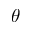<formula> <loc_0><loc_0><loc_500><loc_500>\theta</formula> 